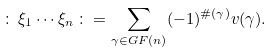<formula> <loc_0><loc_0><loc_500><loc_500>\colon \, \xi _ { 1 } \cdots \xi _ { n } \, \colon = \sum _ { \gamma \in G F ( n ) } ( - 1 ) ^ { \# ( \gamma ) } v ( \gamma ) .</formula> 